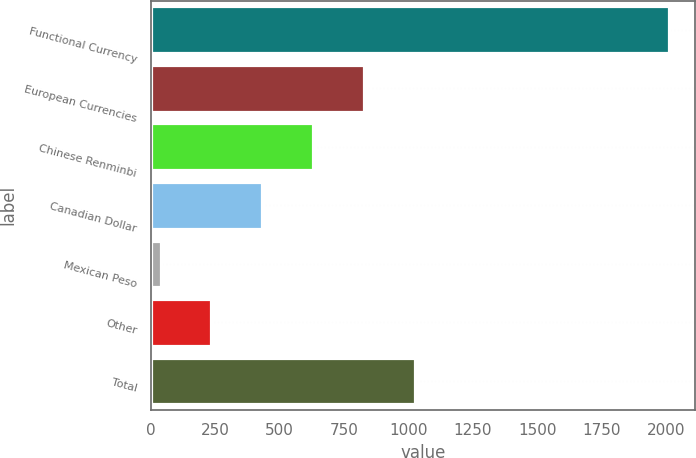<chart> <loc_0><loc_0><loc_500><loc_500><bar_chart><fcel>Functional Currency<fcel>European Currencies<fcel>Chinese Renminbi<fcel>Canadian Dollar<fcel>Mexican Peso<fcel>Other<fcel>Total<nl><fcel>2012<fcel>827.42<fcel>629.99<fcel>432.56<fcel>37.7<fcel>235.13<fcel>1024.85<nl></chart> 